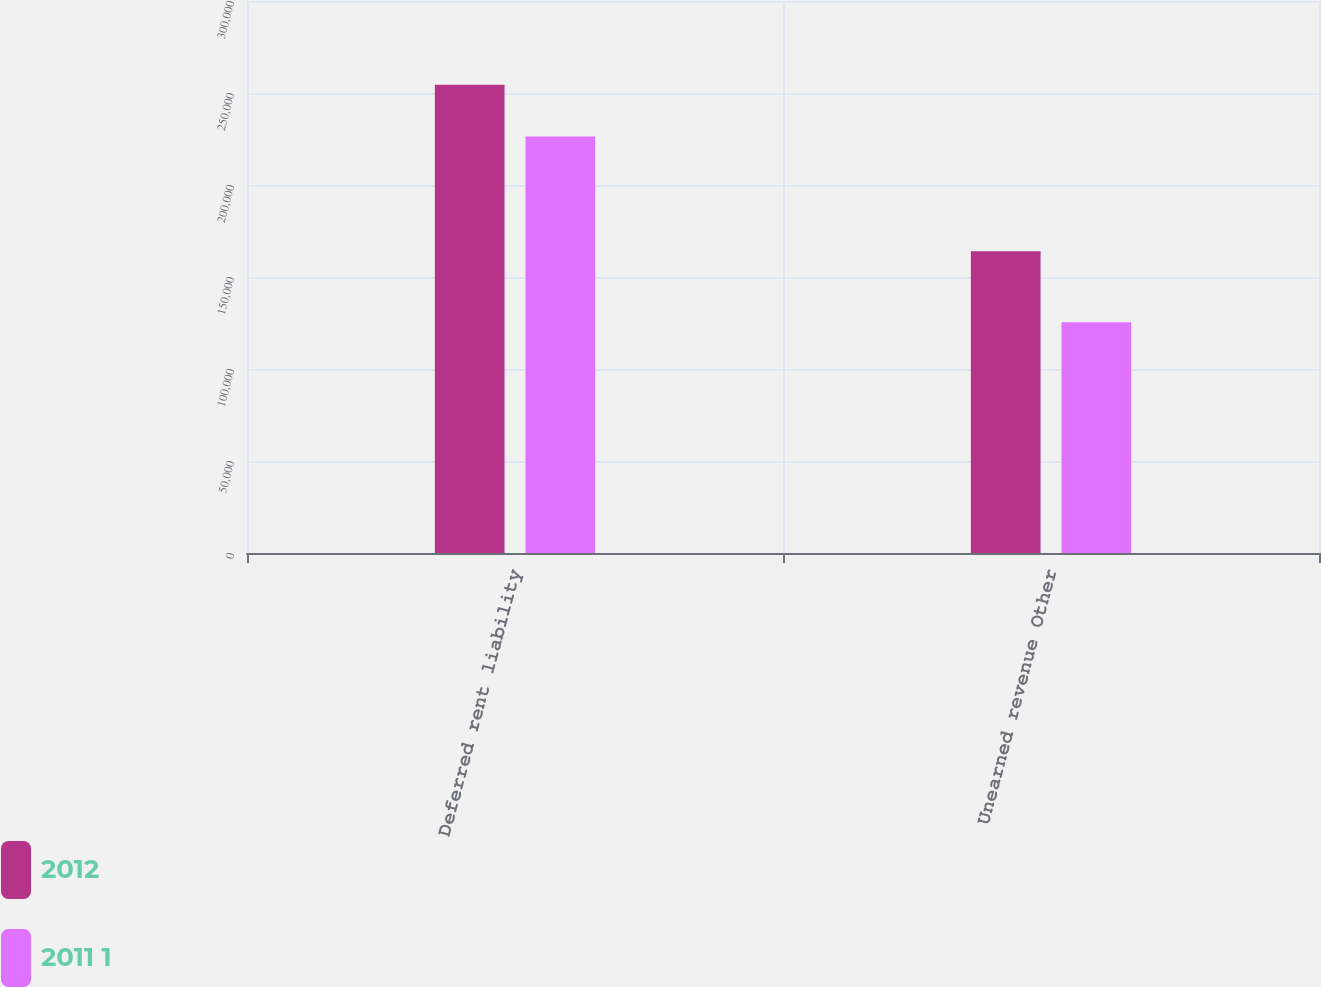<chart> <loc_0><loc_0><loc_500><loc_500><stacked_bar_chart><ecel><fcel>Deferred rent liability<fcel>Unearned revenue Other<nl><fcel>2012<fcel>254494<fcel>164032<nl><fcel>2011 1<fcel>226383<fcel>125472<nl></chart> 